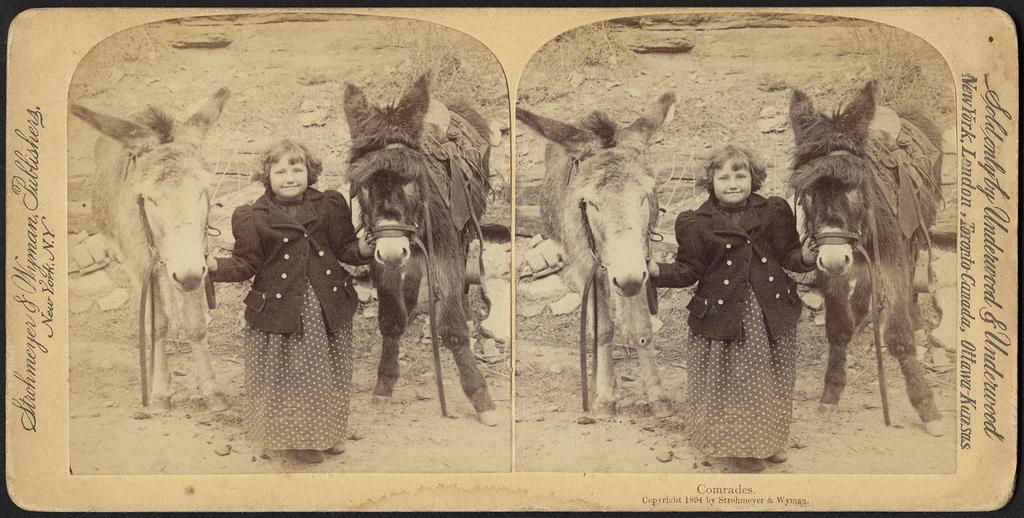In one or two sentences, can you explain what this image depicts? This picture seems to be an edited image. In the foreground there is an object which seems to be the poster containing the text and the depictions. In the foreground we can see the two people standing on the ground and smiling and we can see the animals standing on the ground. In the background we can see the ground, dry stems, rocks and some objects. 